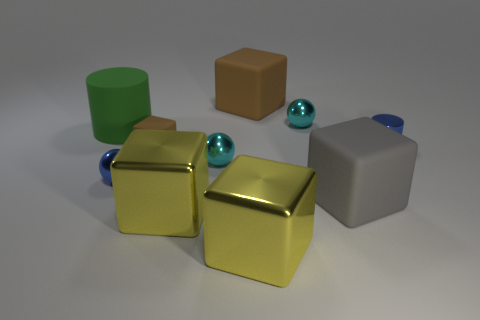How big is the blue metallic cylinder on the right side of the big thing left of the tiny brown rubber block?
Offer a very short reply. Small. How big is the blue cylinder?
Provide a short and direct response. Small. There is a big rubber block that is behind the green object; is its color the same as the tiny matte thing that is in front of the large green cylinder?
Your answer should be compact. Yes. How many other things are there of the same material as the big green thing?
Keep it short and to the point. 3. Are any tiny red cylinders visible?
Provide a succinct answer. No. Is the cyan object in front of the large green cylinder made of the same material as the tiny blue sphere?
Offer a terse response. Yes. There is a small brown thing that is the same shape as the gray rubber object; what is its material?
Offer a terse response. Rubber. There is a object that is the same color as the tiny cylinder; what is it made of?
Ensure brevity in your answer.  Metal. Is the number of matte objects less than the number of large cyan metal spheres?
Keep it short and to the point. No. Does the large matte block that is behind the blue metal cylinder have the same color as the small cube?
Provide a succinct answer. Yes. 